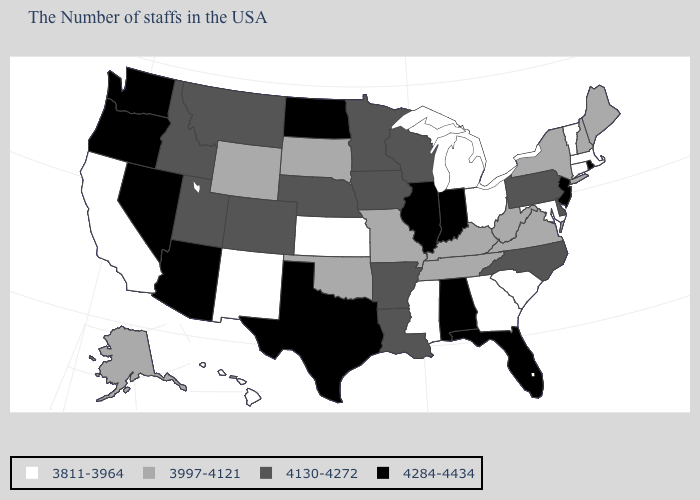What is the value of Vermont?
Write a very short answer. 3811-3964. What is the value of Montana?
Quick response, please. 4130-4272. How many symbols are there in the legend?
Write a very short answer. 4. What is the value of Connecticut?
Quick response, please. 3811-3964. Does Nebraska have the highest value in the MidWest?
Be succinct. No. Does Oregon have the highest value in the USA?
Give a very brief answer. Yes. Which states have the lowest value in the USA?
Short answer required. Massachusetts, Vermont, Connecticut, Maryland, South Carolina, Ohio, Georgia, Michigan, Mississippi, Kansas, New Mexico, California, Hawaii. Which states have the lowest value in the South?
Answer briefly. Maryland, South Carolina, Georgia, Mississippi. Which states have the lowest value in the USA?
Give a very brief answer. Massachusetts, Vermont, Connecticut, Maryland, South Carolina, Ohio, Georgia, Michigan, Mississippi, Kansas, New Mexico, California, Hawaii. Among the states that border North Carolina , does Tennessee have the highest value?
Write a very short answer. Yes. Does the first symbol in the legend represent the smallest category?
Give a very brief answer. Yes. Name the states that have a value in the range 4284-4434?
Answer briefly. Rhode Island, New Jersey, Florida, Indiana, Alabama, Illinois, Texas, North Dakota, Arizona, Nevada, Washington, Oregon. Does Kentucky have a higher value than Massachusetts?
Write a very short answer. Yes. Among the states that border New Hampshire , does Maine have the highest value?
Concise answer only. Yes. Name the states that have a value in the range 3997-4121?
Write a very short answer. Maine, New Hampshire, New York, Virginia, West Virginia, Kentucky, Tennessee, Missouri, Oklahoma, South Dakota, Wyoming, Alaska. 